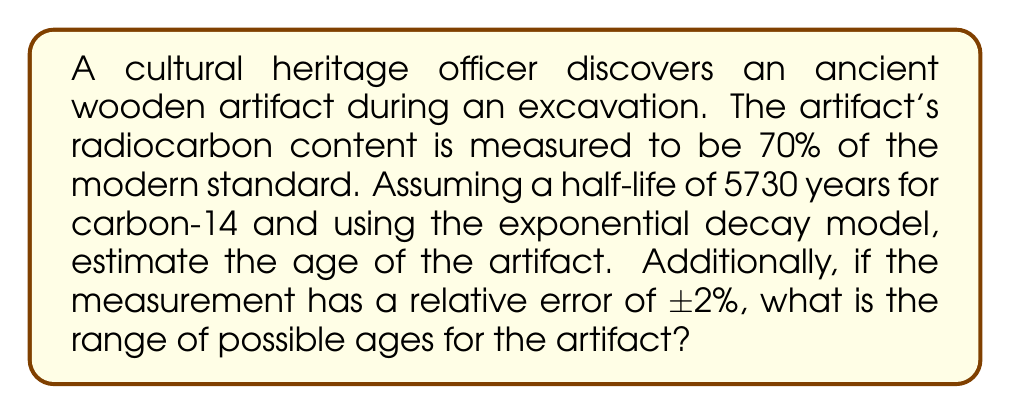Solve this math problem. Let's approach this problem step-by-step:

1) The exponential decay model for radiocarbon dating is given by:

   $$N(t) = N_0 e^{-\lambda t}$$

   where $N(t)$ is the amount of carbon-14 at time $t$, $N_0$ is the initial amount, and $\lambda$ is the decay constant.

2) We're given that the current amount is 70% of the modern standard, so:

   $$\frac{N(t)}{N_0} = 0.70$$

3) The decay constant $\lambda$ is related to the half-life $T_{1/2}$ by:

   $$\lambda = \frac{\ln(2)}{T_{1/2}} = \frac{\ln(2)}{5730} \approx 1.21 \times 10^{-4} \text{ year}^{-1}$$

4) Substituting into the decay equation:

   $$0.70 = e^{-\lambda t}$$

5) Taking natural log of both sides:

   $$\ln(0.70) = -\lambda t$$

6) Solving for $t$:

   $$t = -\frac{\ln(0.70)}{\lambda} \approx 2949 \text{ years}$$

7) For the error analysis, we use the fact that the measurement has a relative error of ±2%. This means the actual fraction could be between 0.686 and 0.714.

8) Repeating steps 4-6 with these values:

   For 0.686: $t \approx 3092 \text{ years}$
   For 0.714: $t \approx 2808 \text{ years}$

Therefore, the range of possible ages is approximately 2808 to 3092 years.
Answer: 2949 ± 143 years 